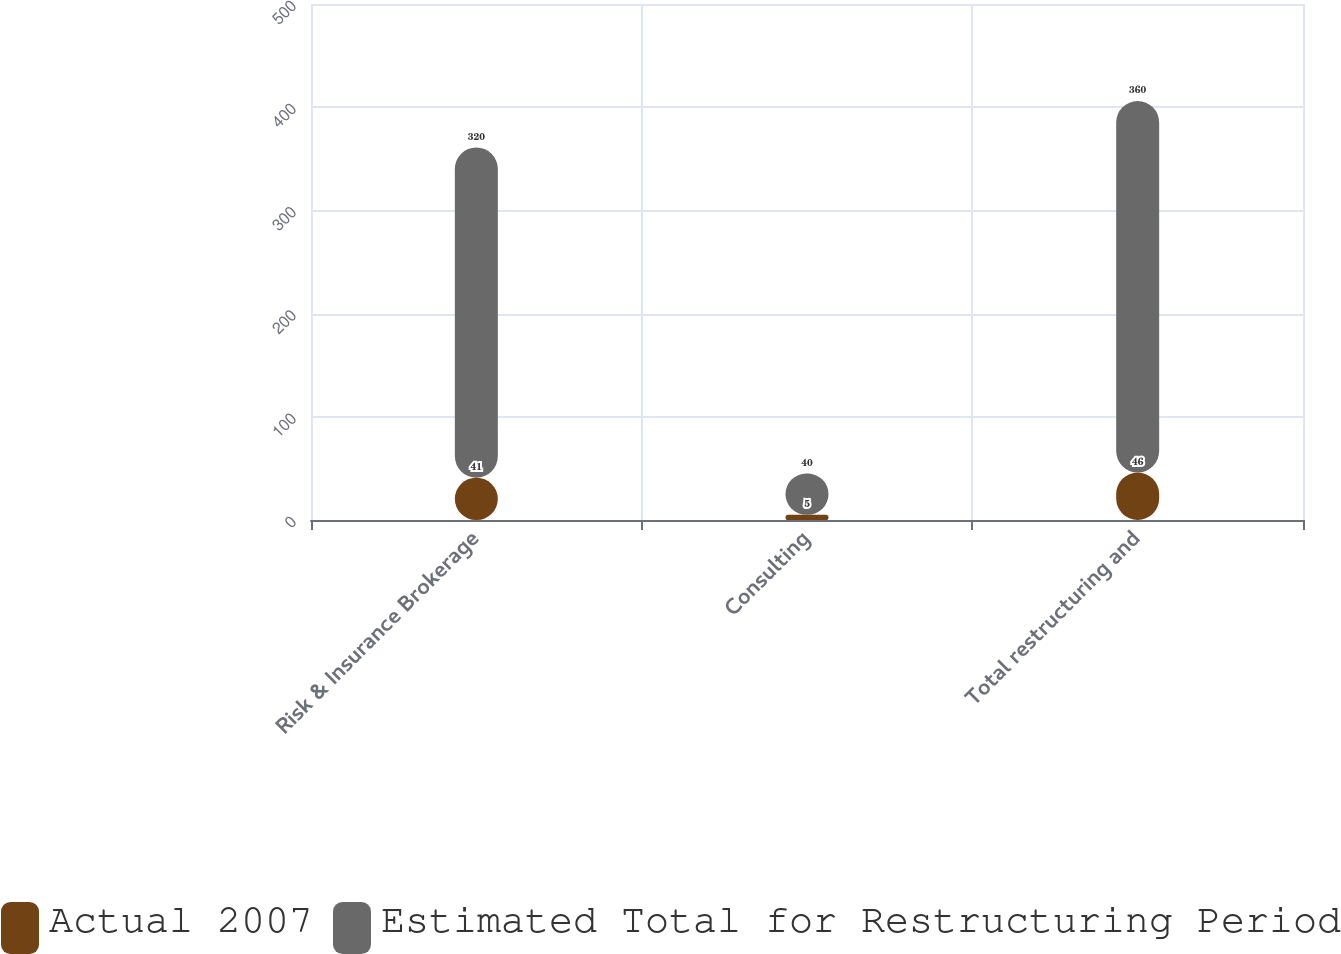<chart> <loc_0><loc_0><loc_500><loc_500><stacked_bar_chart><ecel><fcel>Risk & Insurance Brokerage<fcel>Consulting<fcel>Total restructuring and<nl><fcel>Actual 2007<fcel>41<fcel>5<fcel>46<nl><fcel>Estimated Total for Restructuring Period<fcel>320<fcel>40<fcel>360<nl></chart> 